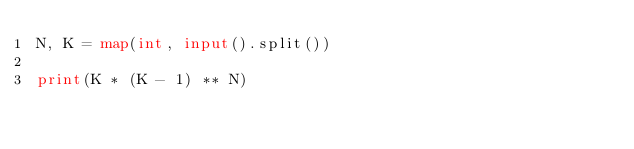<code> <loc_0><loc_0><loc_500><loc_500><_Python_>N, K = map(int, input().split())

print(K * (K - 1) ** N)
</code> 